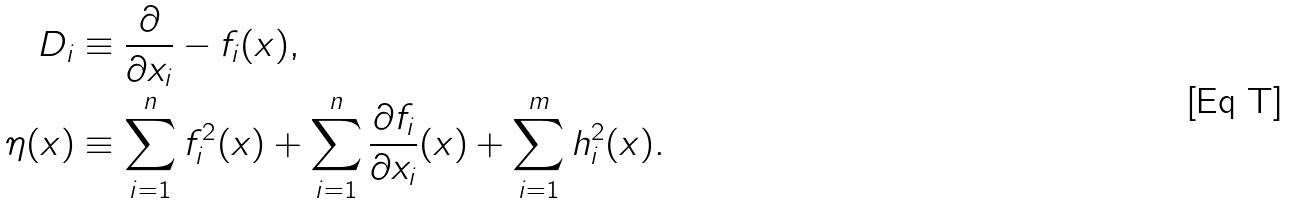Convert formula to latex. <formula><loc_0><loc_0><loc_500><loc_500>D _ { i } & \equiv \frac { \partial } { \partial x _ { i } } - f _ { i } ( x ) , \\ \eta ( x ) & \equiv \sum _ { i = 1 } ^ { n } f _ { i } ^ { 2 } ( x ) + \sum _ { i = 1 } ^ { n } \frac { \partial f _ { i } } { \partial x _ { i } } ( x ) + \sum _ { i = 1 } ^ { m } h _ { i } ^ { 2 } ( x ) .</formula> 